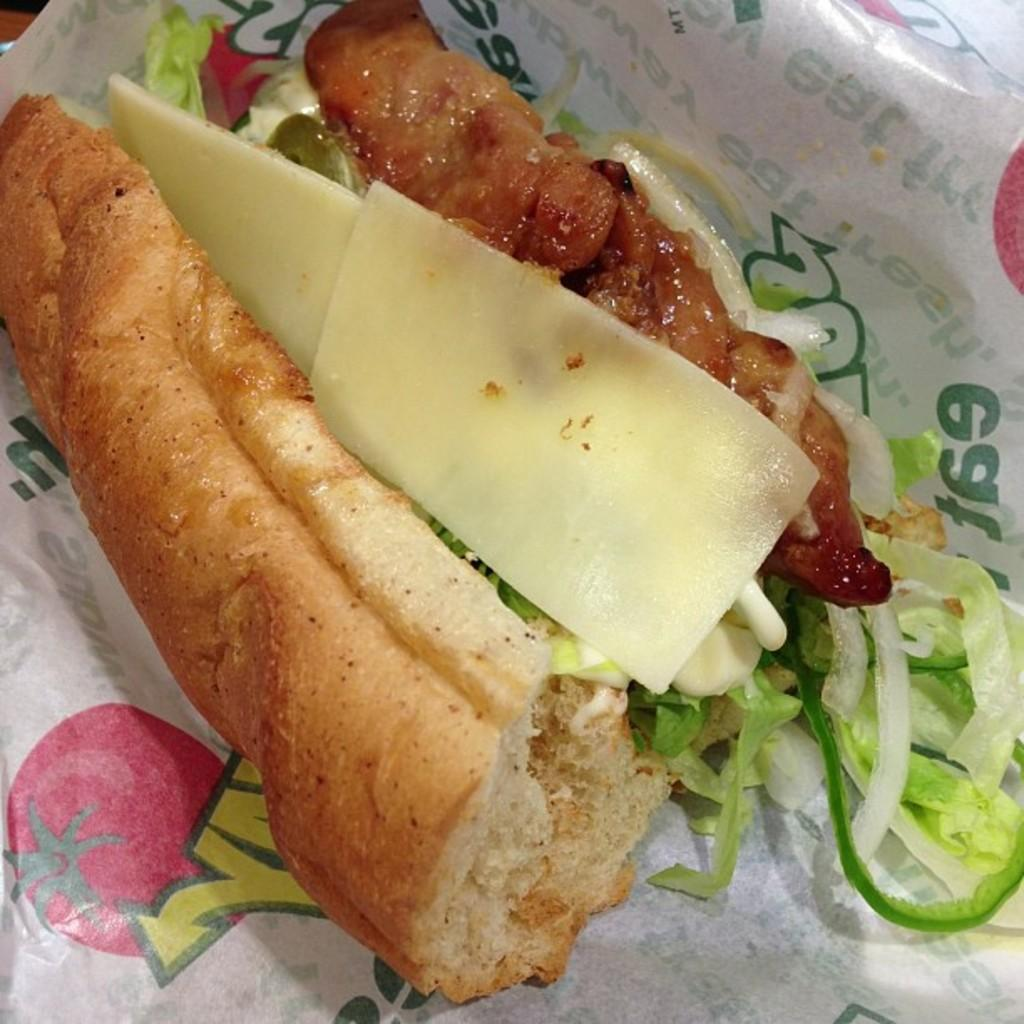What can be seen in the image related to food? There is a food item in the image. What else is present in the image besides the food? There is a tissue paper in the image. How many cherries are on the book in the image? There is no book or cherries present in the image. What type of jar is visible on the table in the image? There is no jar present in the image. 